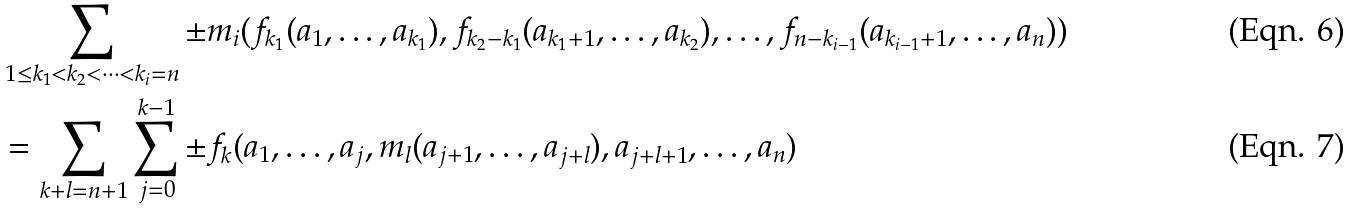<formula> <loc_0><loc_0><loc_500><loc_500>& \sum _ { 1 \leq k _ { 1 } < k _ { 2 } < \dots < k _ { i } = n } \pm m _ { i } ( f _ { k _ { 1 } } ( a _ { 1 } , \dots , a _ { k _ { 1 } } ) , f _ { k _ { 2 } - k _ { 1 } } ( a _ { k _ { 1 } + 1 } , \dots , a _ { k _ { 2 } } ) , \dots , f _ { n - k _ { i - 1 } } ( a _ { k _ { i - 1 } + 1 } , \dots , a _ { n } ) ) \\ & = \sum _ { k + l = n + 1 } \sum _ { j = 0 } ^ { k - 1 } \pm f _ { k } ( a _ { 1 } , \dots , a _ { j } , m _ { l } ( a _ { j + 1 } , \dots , a _ { j + l } ) , a _ { j + l + 1 } , \dots , a _ { n } )</formula> 